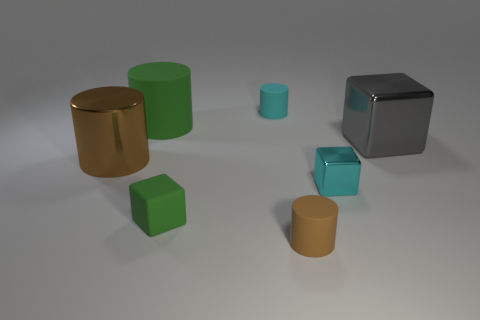Can you tell me the colors and shapes of the objects in the image? Certainly! There are metallic and matte objects in various shapes. For colors, there's a metallic grey cube, two green objects – one cylinder, one cube, two matte brown cylinders, and a cyan cube with a reflective surface. The shapes include three cylinders and three cubes. 